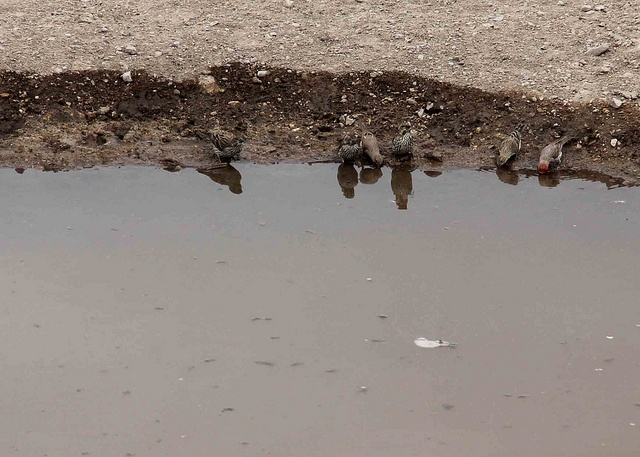Describe the objects in this image and their specific colors. I can see bird in tan, black, and gray tones, bird in tan, black, gray, and darkgray tones, bird in tan, gray, darkgray, and black tones, bird in tan, gray, and black tones, and bird in tan, gray, maroon, and black tones in this image. 